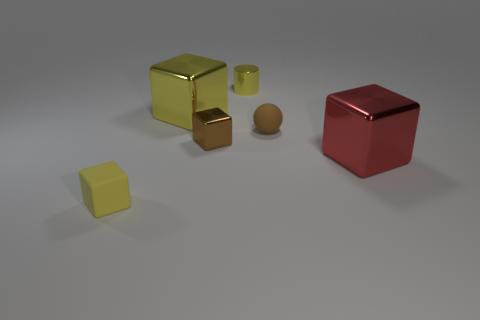What number of other things are the same size as the brown metallic cube?
Make the answer very short. 3. Are there fewer cyan metal cubes than shiny cubes?
Provide a succinct answer. Yes. The brown metallic thing has what shape?
Provide a short and direct response. Cube. There is a small shiny thing to the left of the yellow metal cylinder; does it have the same color as the ball?
Offer a very short reply. Yes. There is a metallic thing that is to the left of the yellow cylinder and to the right of the large yellow cube; what is its shape?
Your response must be concise. Cube. The large shiny thing to the left of the brown matte ball is what color?
Your answer should be compact. Yellow. Is there any other thing that is the same color as the tiny matte block?
Offer a very short reply. Yes. Do the rubber block and the brown shiny cube have the same size?
Your response must be concise. Yes. There is a object that is to the left of the brown block and on the right side of the small rubber cube; what size is it?
Your response must be concise. Large. How many brown things are made of the same material as the big yellow block?
Provide a succinct answer. 1. 